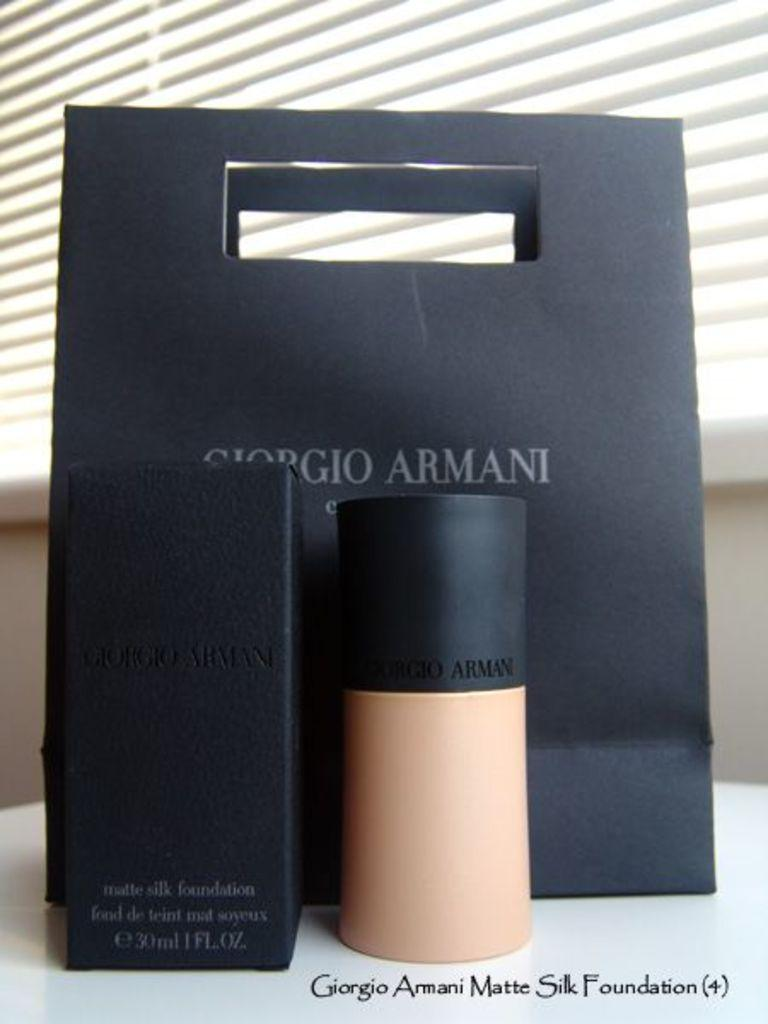<image>
Give a short and clear explanation of the subsequent image. A black Giorgio Armani bag with a flesh colored container of foundation in front of it as well as the black cardboard container. 